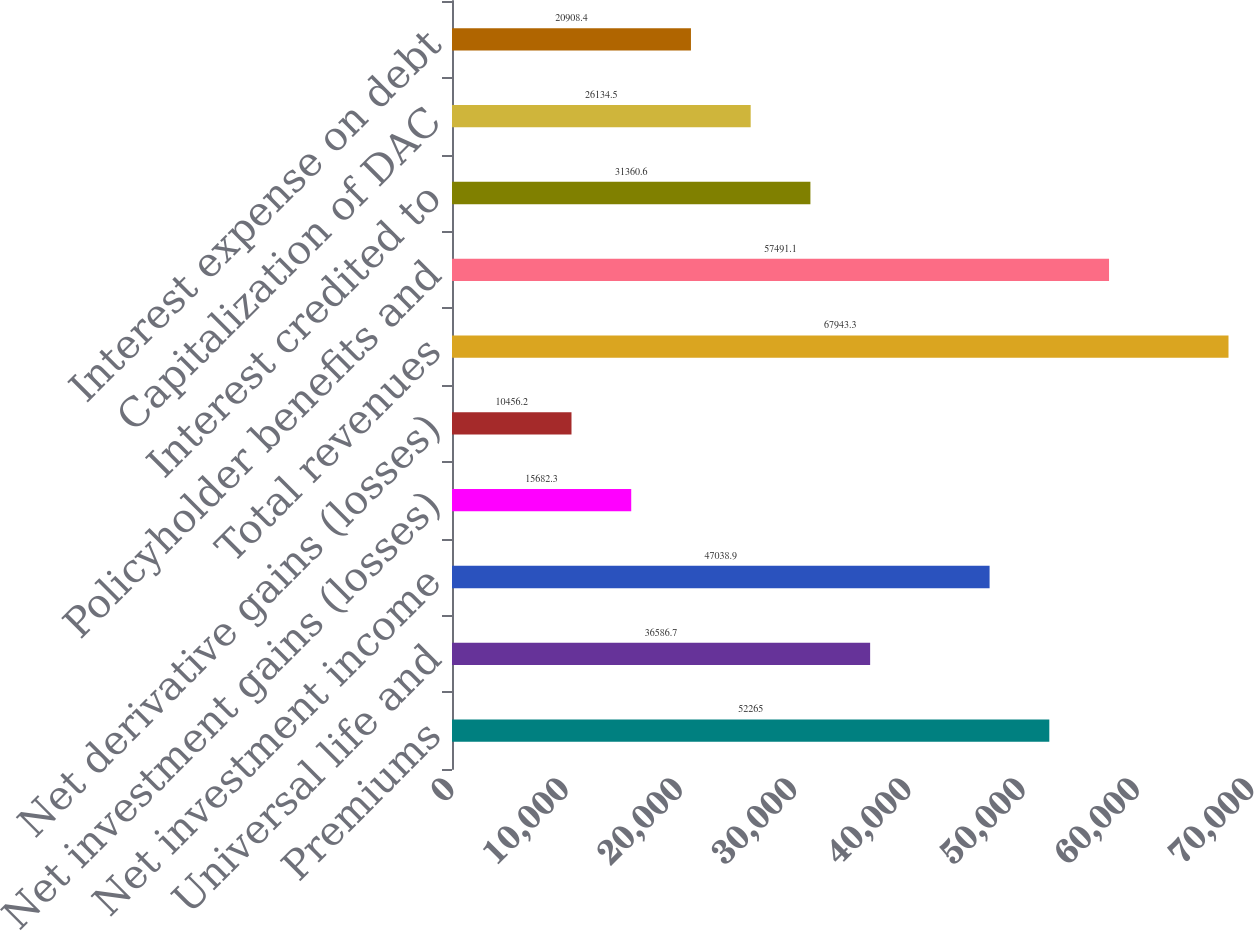Convert chart to OTSL. <chart><loc_0><loc_0><loc_500><loc_500><bar_chart><fcel>Premiums<fcel>Universal life and<fcel>Net investment income<fcel>Net investment gains (losses)<fcel>Net derivative gains (losses)<fcel>Total revenues<fcel>Policyholder benefits and<fcel>Interest credited to<fcel>Capitalization of DAC<fcel>Interest expense on debt<nl><fcel>52265<fcel>36586.7<fcel>47038.9<fcel>15682.3<fcel>10456.2<fcel>67943.3<fcel>57491.1<fcel>31360.6<fcel>26134.5<fcel>20908.4<nl></chart> 